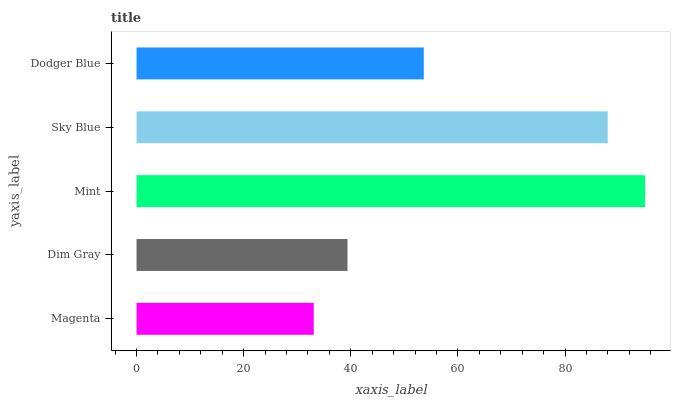Is Magenta the minimum?
Answer yes or no. Yes. Is Mint the maximum?
Answer yes or no. Yes. Is Dim Gray the minimum?
Answer yes or no. No. Is Dim Gray the maximum?
Answer yes or no. No. Is Dim Gray greater than Magenta?
Answer yes or no. Yes. Is Magenta less than Dim Gray?
Answer yes or no. Yes. Is Magenta greater than Dim Gray?
Answer yes or no. No. Is Dim Gray less than Magenta?
Answer yes or no. No. Is Dodger Blue the high median?
Answer yes or no. Yes. Is Dodger Blue the low median?
Answer yes or no. Yes. Is Dim Gray the high median?
Answer yes or no. No. Is Mint the low median?
Answer yes or no. No. 